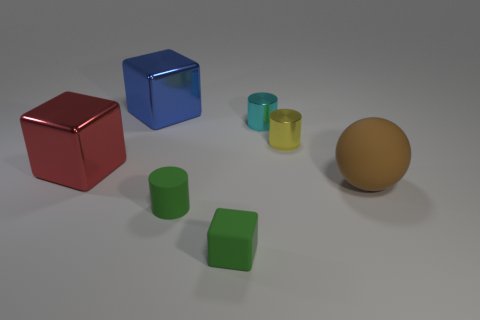What material is the yellow object that is the same shape as the cyan metallic thing?
Ensure brevity in your answer.  Metal. There is a large rubber object in front of the large blue metal thing; is there a tiny cylinder that is in front of it?
Your response must be concise. Yes. Does the yellow object have the same shape as the large red object?
Your response must be concise. No. What is the shape of the red object that is the same material as the tiny cyan object?
Give a very brief answer. Cube. Is the size of the cube that is in front of the ball the same as the object that is to the left of the blue object?
Make the answer very short. No. Are there more big shiny things that are behind the yellow thing than large things that are in front of the large matte thing?
Make the answer very short. Yes. What number of other things are there of the same color as the tiny rubber block?
Give a very brief answer. 1. Does the tiny cube have the same color as the small cylinder in front of the sphere?
Provide a succinct answer. Yes. What number of tiny things are in front of the cylinder behind the yellow object?
Offer a very short reply. 3. What is the material of the block that is to the right of the large metallic thing that is behind the big red shiny cube left of the tiny green cylinder?
Provide a succinct answer. Rubber. 